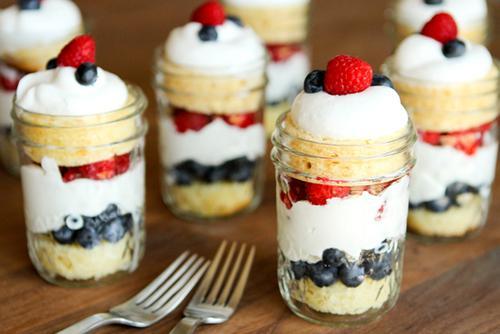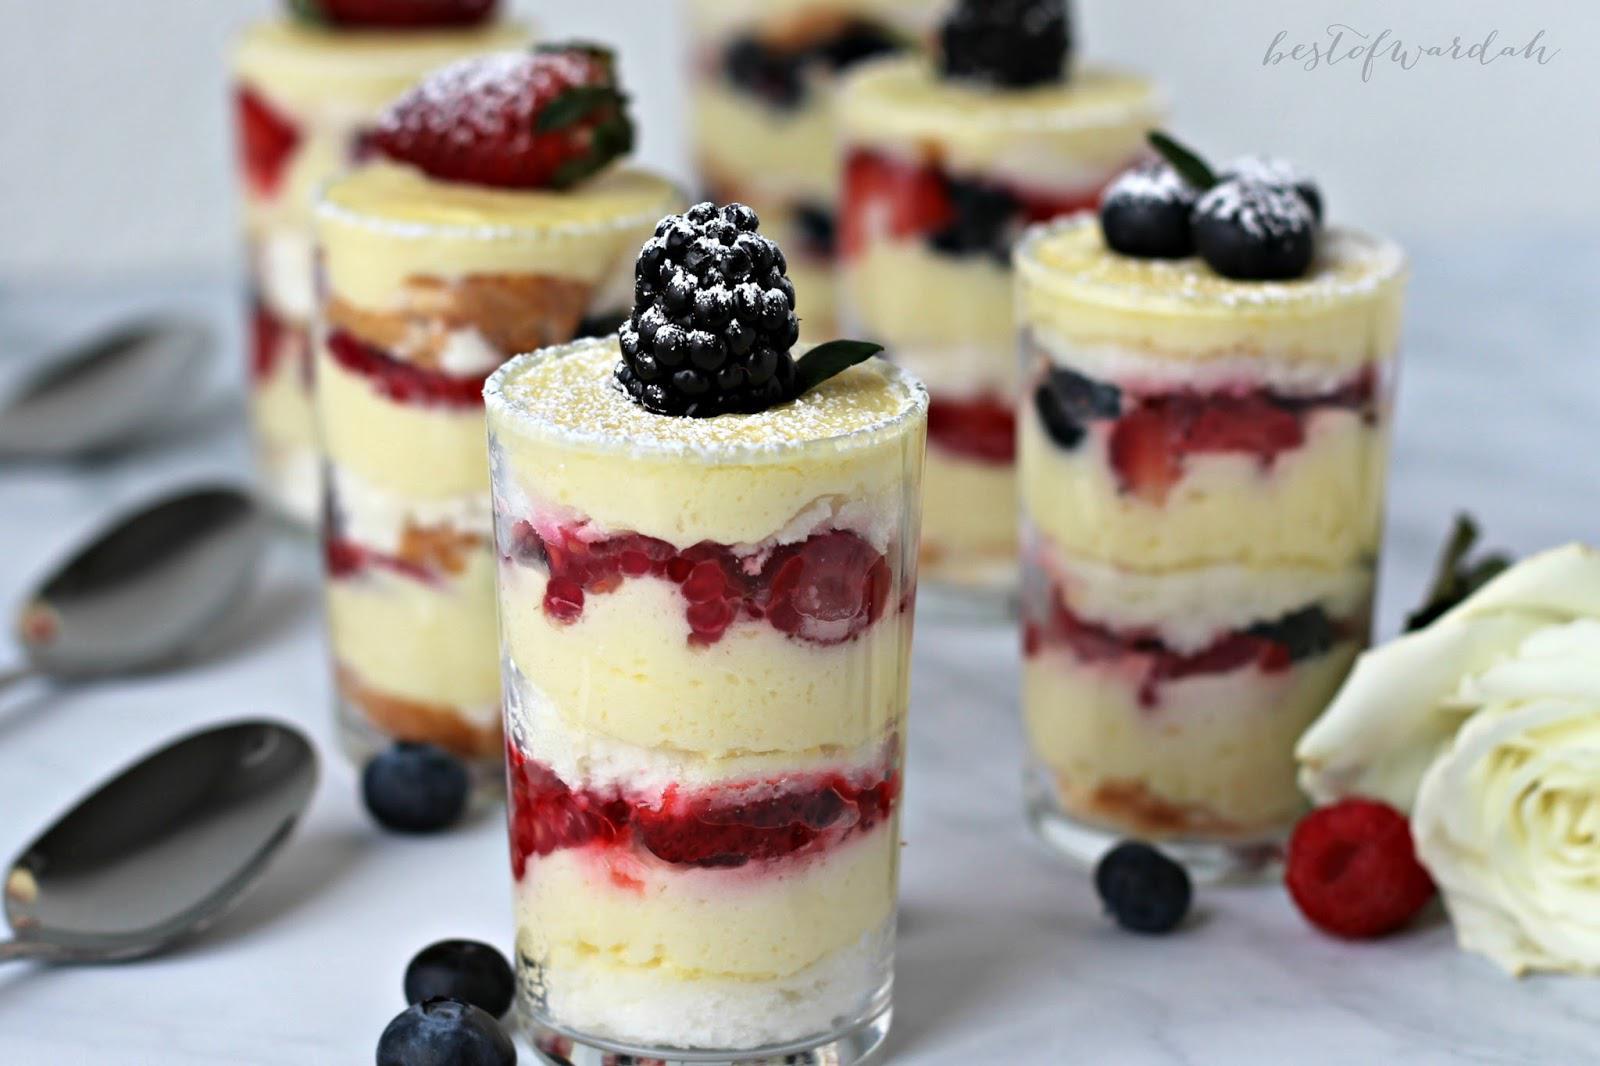The first image is the image on the left, the second image is the image on the right. For the images shown, is this caption "Each image is a display of at least three individual trifle desserts that are topped with pieces of whole fruit." true? Answer yes or no. Yes. The first image is the image on the left, the second image is the image on the right. Given the left and right images, does the statement "An image shows single-serve desserts garnished with blueberries and red raspberries." hold true? Answer yes or no. Yes. 